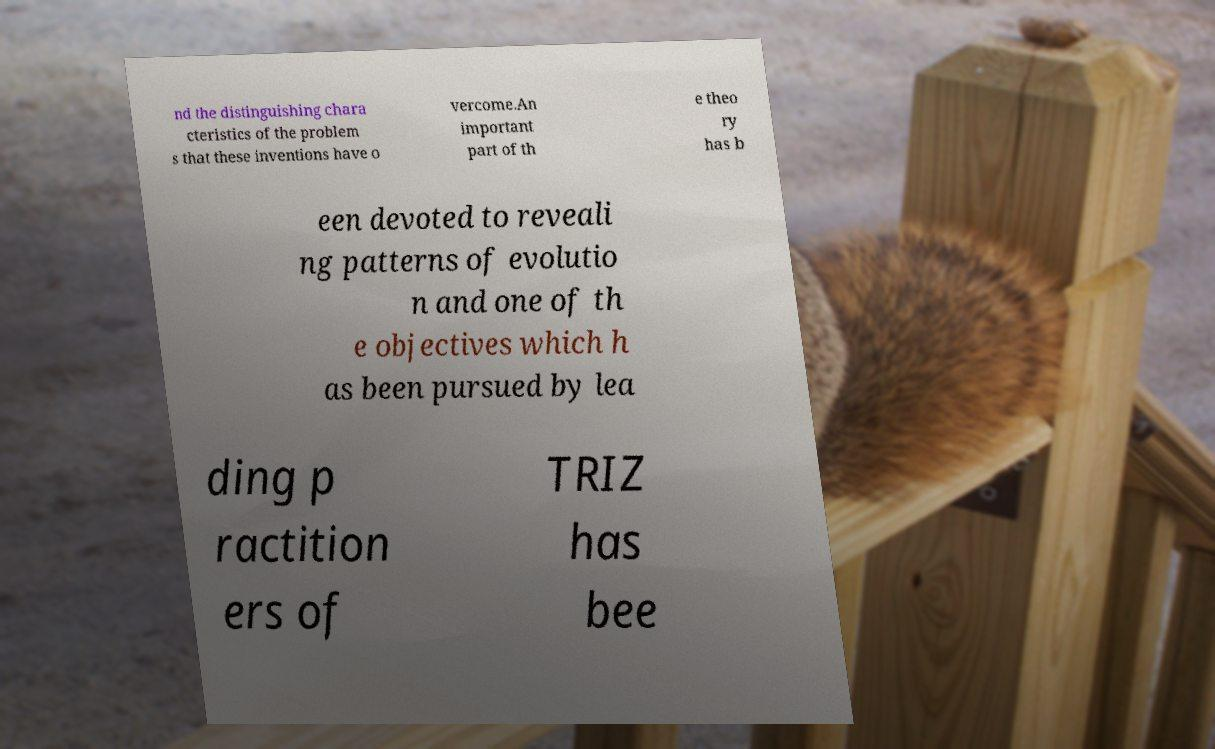There's text embedded in this image that I need extracted. Can you transcribe it verbatim? nd the distinguishing chara cteristics of the problem s that these inventions have o vercome.An important part of th e theo ry has b een devoted to reveali ng patterns of evolutio n and one of th e objectives which h as been pursued by lea ding p ractition ers of TRIZ has bee 